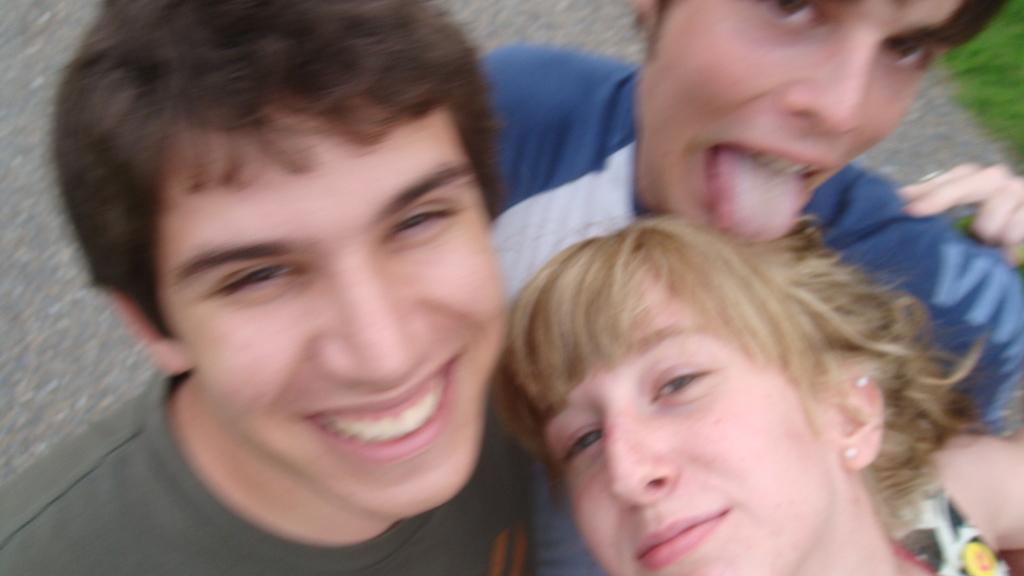Please provide a concise description of this image. In this picture there is a man who is sitting. Beside him there is another man who is wearing a white and blue t-shirt. In the bottom right corner there is a woman who is wearing t-shirt and earring. They are smiling. They are standing on the ground. In the top right corner I can see the grass. 